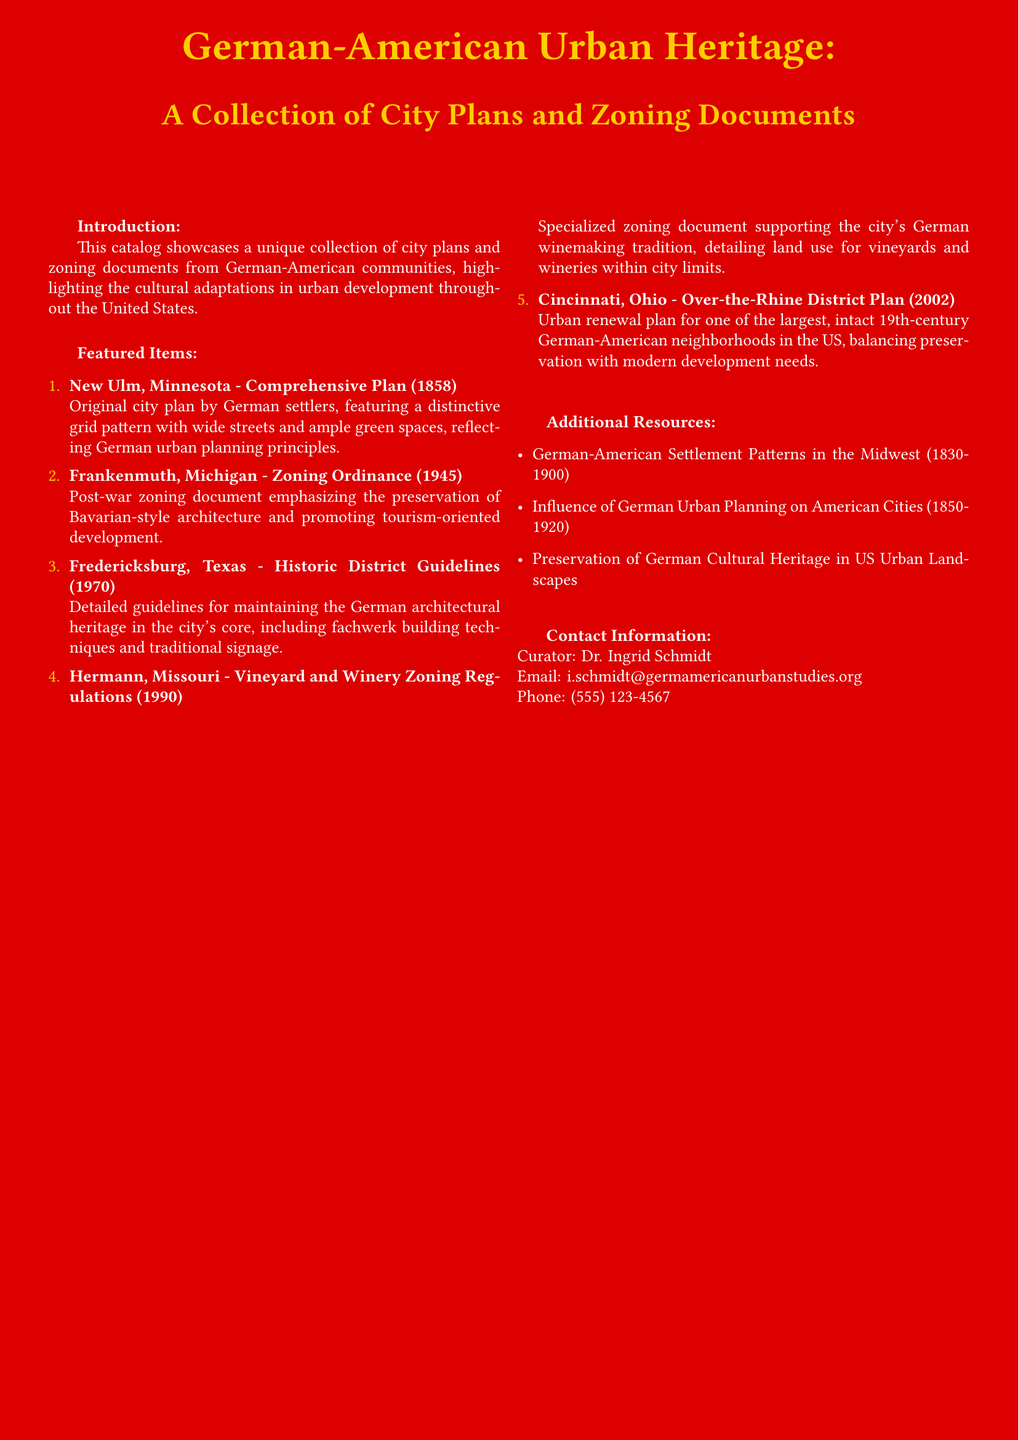What year was the comprehensive plan for New Ulm, Minnesota created? The document states that the comprehensive plan was created in 1858.
Answer: 1858 What architectural style is emphasized in the Frankenmuth zoning ordinance? The zoning ordinance emphasizes the preservation of Bavarian-style architecture.
Answer: Bavarian-style Which community's guidelines focus on fachwerk building techniques? The guidelines mentioned are for Fredericksburg, Texas.
Answer: Fredericksburg, Texas What special zoning regulations support Hermann's tradition? The regulations specifically support the city's German winemaking tradition.
Answer: German winemaking tradition What is the contact email for the curator? The document lists Dr. Ingrid Schmidt's email for contact.
Answer: i.schmidt@germamericanurbanstudies.org How many featured items are listed in the document? The document lists five featured items under city plans and zoning documents.
Answer: Five What are the additional resources related to German-American urban heritage? The additional resources detail settlement patterns, urban planning influence, and cultural preservation.
Answer: Settlement patterns, urban planning influence, cultural preservation What does the tagline at the bottom of the document say? The tagline emphasizes the importance of preserving the German-American urban legacy.
Answer: "Preserving Our German-American Urban Legacy" 